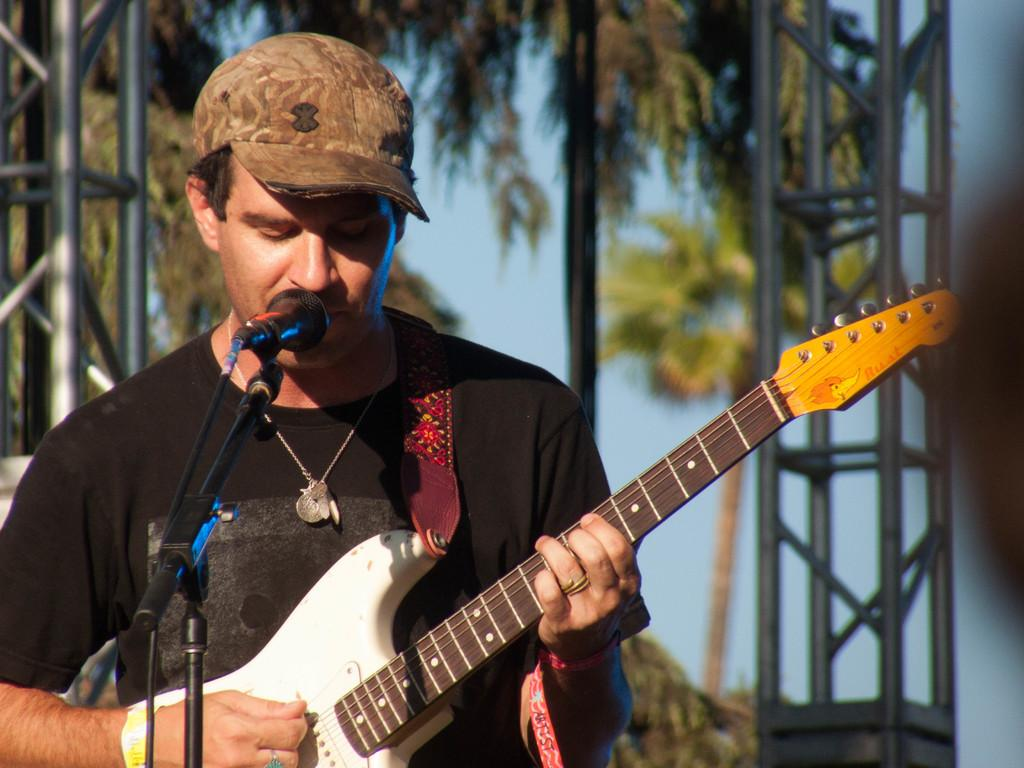What is the main subject of the image? The main subject of the image is a man. What is the man wearing on his head? The man is wearing a cap. What is the man holding in the image? The man is holding a guitar. What is the man doing with the guitar? The man is playing the guitar. What is in front of the man for amplifying his voice? There is a microphone in front of the man. What is the microphone attached to in the image? The microphone is attached to a microphone stand. What can be seen in the background of the image? There are trees, stands, and the sky visible in the background of the image. What type of flag is visible in the image? There is no flag present in the image. What type of gate can be seen in the background of the image? There is no gate present in the image; only trees, stands, and the sky are visible in the background. 